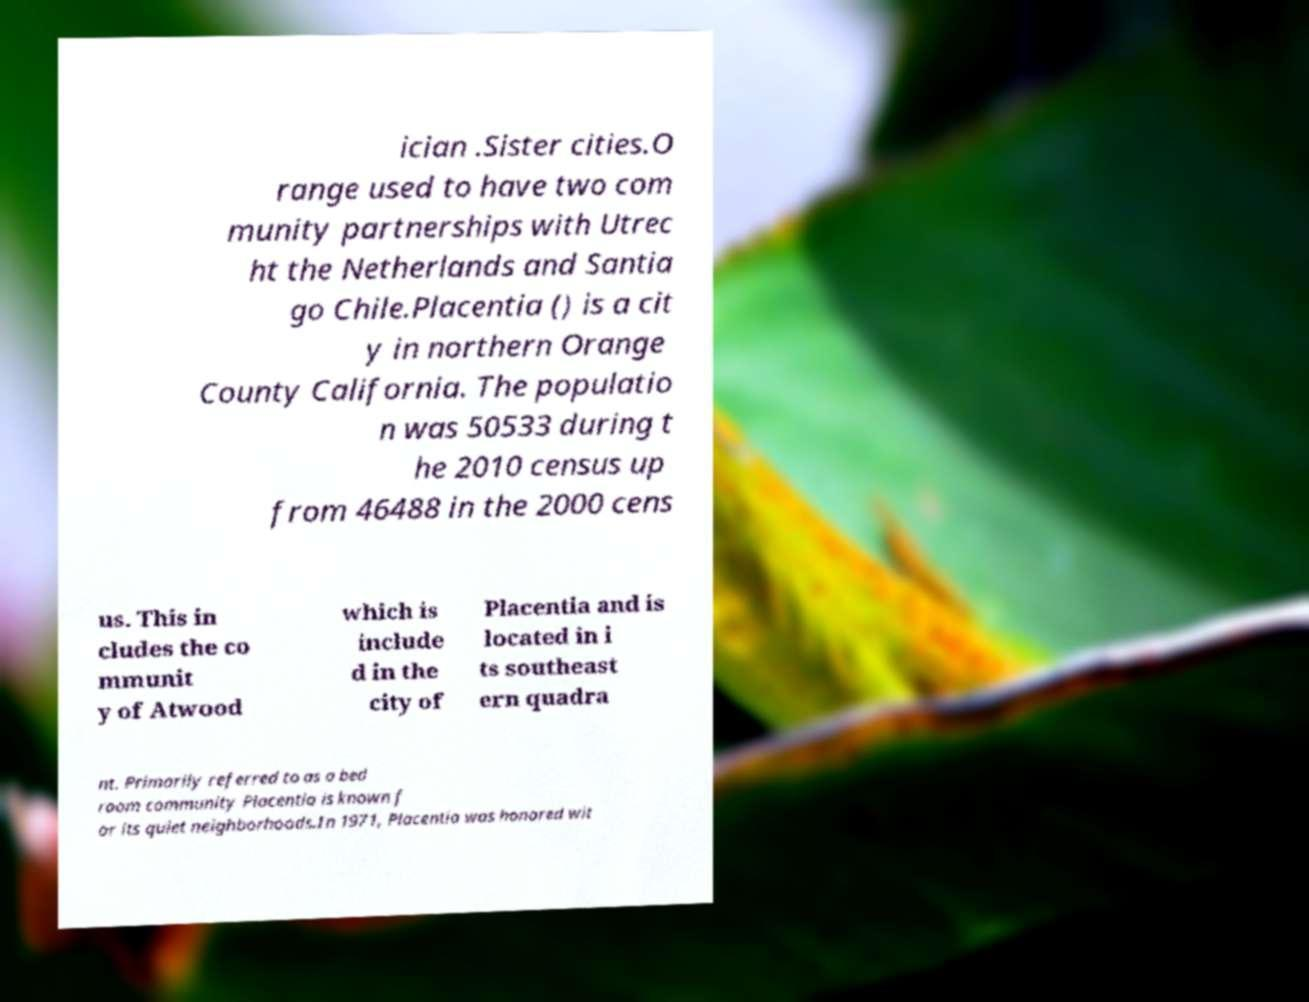There's text embedded in this image that I need extracted. Can you transcribe it verbatim? ician .Sister cities.O range used to have two com munity partnerships with Utrec ht the Netherlands and Santia go Chile.Placentia () is a cit y in northern Orange County California. The populatio n was 50533 during t he 2010 census up from 46488 in the 2000 cens us. This in cludes the co mmunit y of Atwood which is include d in the city of Placentia and is located in i ts southeast ern quadra nt. Primarily referred to as a bed room community Placentia is known f or its quiet neighborhoods.In 1971, Placentia was honored wit 